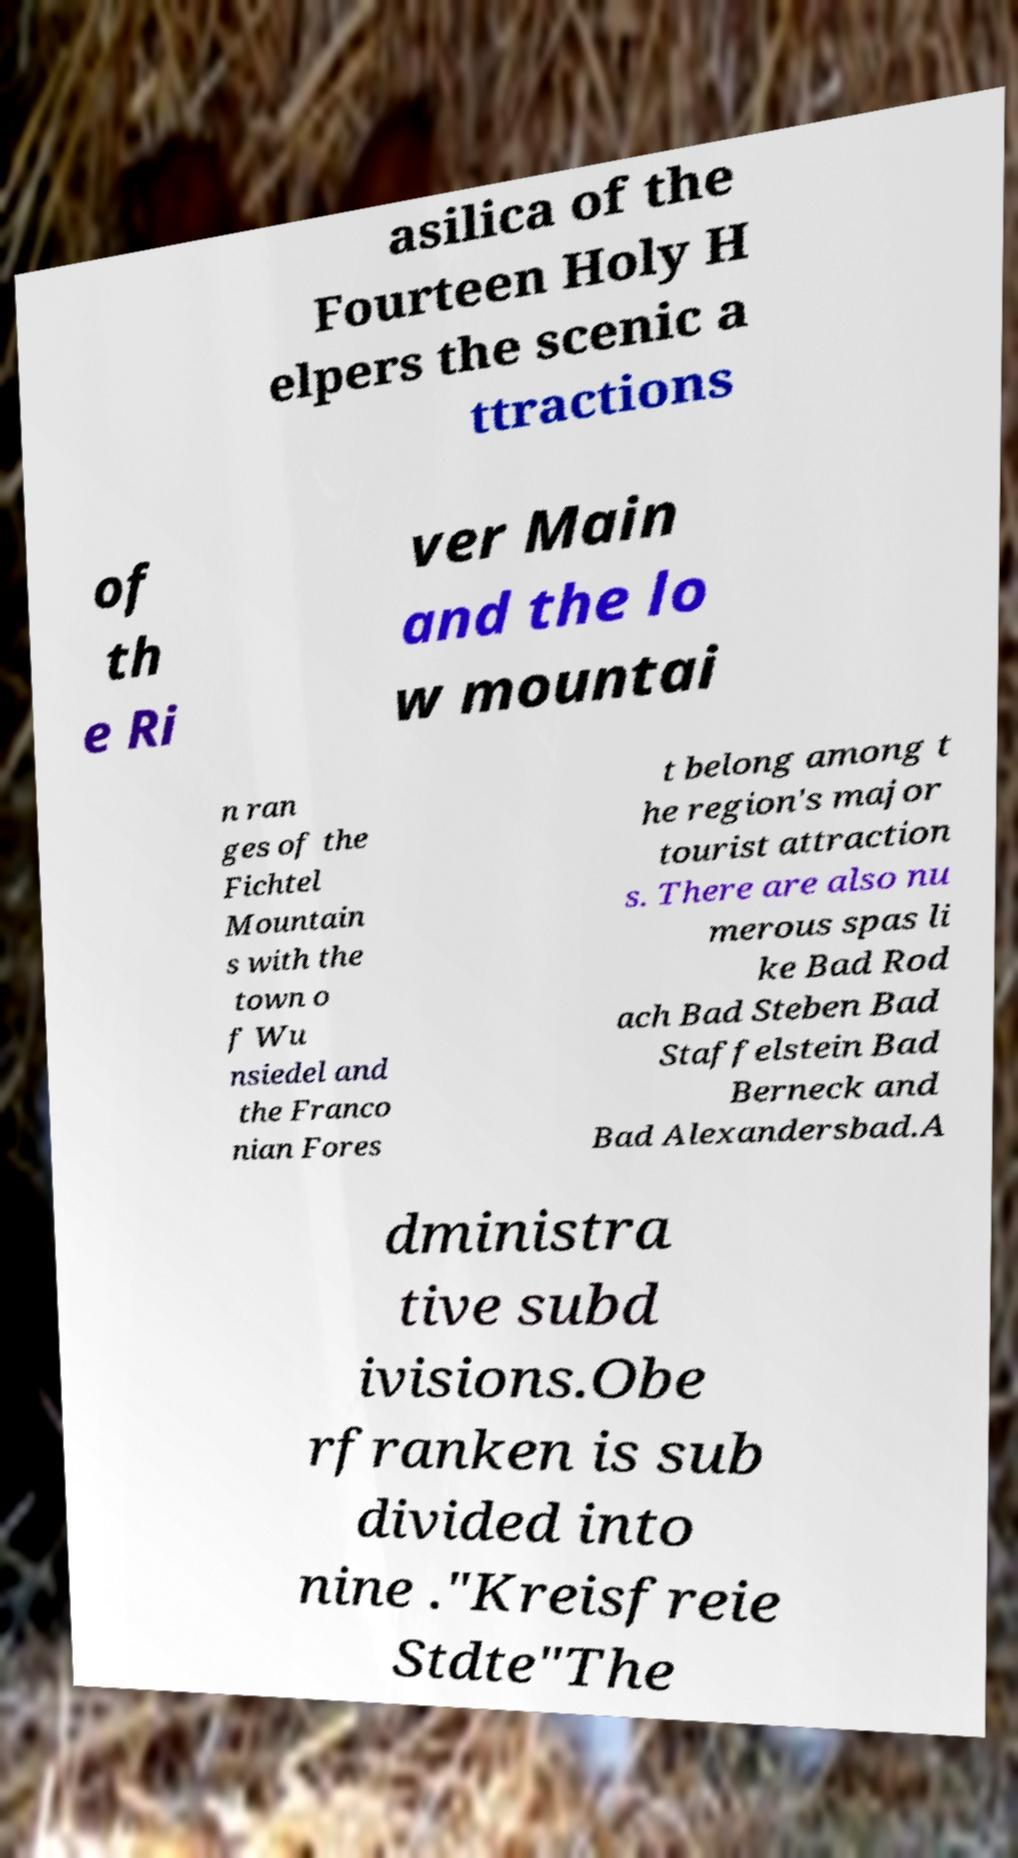Could you assist in decoding the text presented in this image and type it out clearly? asilica of the Fourteen Holy H elpers the scenic a ttractions of th e Ri ver Main and the lo w mountai n ran ges of the Fichtel Mountain s with the town o f Wu nsiedel and the Franco nian Fores t belong among t he region's major tourist attraction s. There are also nu merous spas li ke Bad Rod ach Bad Steben Bad Staffelstein Bad Berneck and Bad Alexandersbad.A dministra tive subd ivisions.Obe rfranken is sub divided into nine ."Kreisfreie Stdte"The 